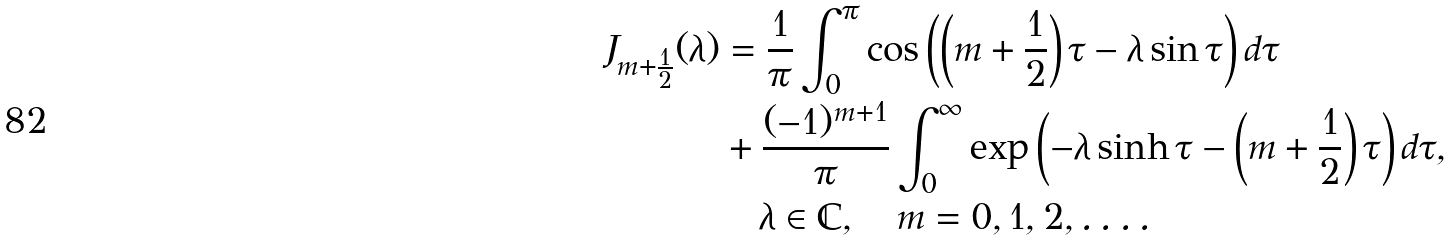Convert formula to latex. <formula><loc_0><loc_0><loc_500><loc_500>J _ { m + \frac { 1 } { 2 } } ( \lambda ) & = \frac { 1 } { \pi } \int _ { 0 } ^ { \pi } \cos \left ( \left ( m + \frac { 1 } { 2 } \right ) \tau - \lambda \sin \tau \right ) d \tau \\ & + \frac { ( - 1 ) ^ { m + 1 } } \pi \int _ { 0 } ^ { \infty } \exp \left ( - \lambda \sinh \tau - \left ( m + \frac { 1 } { 2 } \right ) \tau \right ) d \tau , \\ & \quad \lambda \in \mathbb { C } , \quad m = 0 , 1 , 2 , \dots .</formula> 